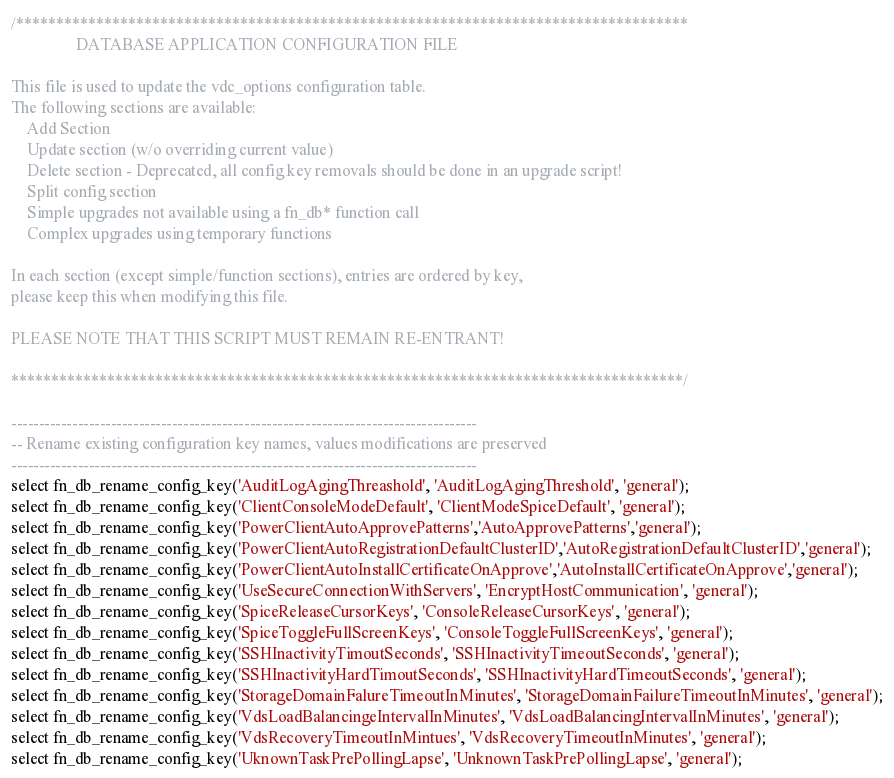Convert code to text. <code><loc_0><loc_0><loc_500><loc_500><_SQL_>/************************************************************************************
                DATABASE APPLICATION CONFIGURATION FILE

This file is used to update the vdc_options configuration table.
The following sections are available:
    Add Section
    Update section (w/o overriding current value)
    Delete section - Deprecated, all config key removals should be done in an upgrade script!
    Split config section
    Simple upgrades not available using a fn_db* function call
    Complex upgrades using temporary functions

In each section (except simple/function sections), entries are ordered by key,
please keep this when modifying this file.

PLEASE NOTE THAT THIS SCRIPT MUST REMAIN RE-ENTRANT!

************************************************************************************/

------------------------------------------------------------------------------------
-- Rename existing configuration key names, values modifications are preserved
------------------------------------------------------------------------------------
select fn_db_rename_config_key('AuditLogAgingThreashold', 'AuditLogAgingThreshold', 'general');
select fn_db_rename_config_key('ClientConsoleModeDefault', 'ClientModeSpiceDefault', 'general');
select fn_db_rename_config_key('PowerClientAutoApprovePatterns','AutoApprovePatterns','general');
select fn_db_rename_config_key('PowerClientAutoRegistrationDefaultClusterID','AutoRegistrationDefaultClusterID','general');
select fn_db_rename_config_key('PowerClientAutoInstallCertificateOnApprove','AutoInstallCertificateOnApprove','general');
select fn_db_rename_config_key('UseSecureConnectionWithServers', 'EncryptHostCommunication', 'general');
select fn_db_rename_config_key('SpiceReleaseCursorKeys', 'ConsoleReleaseCursorKeys', 'general');
select fn_db_rename_config_key('SpiceToggleFullScreenKeys', 'ConsoleToggleFullScreenKeys', 'general');
select fn_db_rename_config_key('SSHInactivityTimoutSeconds', 'SSHInactivityTimeoutSeconds', 'general');
select fn_db_rename_config_key('SSHInactivityHardTimoutSeconds', 'SSHInactivityHardTimeoutSeconds', 'general');
select fn_db_rename_config_key('StorageDomainFalureTimeoutInMinutes', 'StorageDomainFailureTimeoutInMinutes', 'general');
select fn_db_rename_config_key('VdsLoadBalancingeIntervalInMinutes', 'VdsLoadBalancingIntervalInMinutes', 'general');
select fn_db_rename_config_key('VdsRecoveryTimeoutInMintues', 'VdsRecoveryTimeoutInMinutes', 'general');
select fn_db_rename_config_key('UknownTaskPrePollingLapse', 'UnknownTaskPrePollingLapse', 'general');</code> 